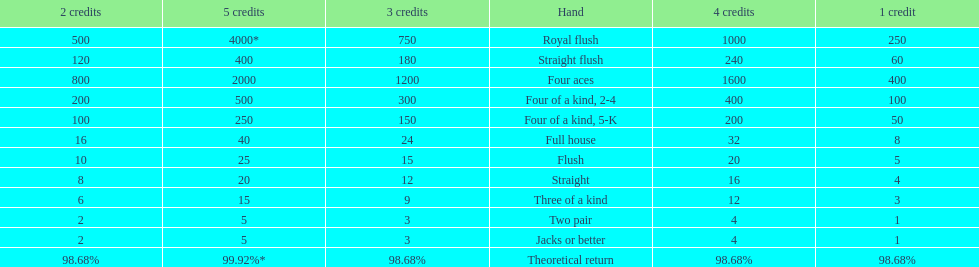What's the best type of four of a kind to win? Four of a kind, 2-4. Can you give me this table as a dict? {'header': ['2 credits', '5 credits', '3 credits', 'Hand', '4 credits', '1 credit'], 'rows': [['500', '4000*', '750', 'Royal flush', '1000', '250'], ['120', '400', '180', 'Straight flush', '240', '60'], ['800', '2000', '1200', 'Four aces', '1600', '400'], ['200', '500', '300', 'Four of a kind, 2-4', '400', '100'], ['100', '250', '150', 'Four of a kind, 5-K', '200', '50'], ['16', '40', '24', 'Full house', '32', '8'], ['10', '25', '15', 'Flush', '20', '5'], ['8', '20', '12', 'Straight', '16', '4'], ['6', '15', '9', 'Three of a kind', '12', '3'], ['2', '5', '3', 'Two pair', '4', '1'], ['2', '5', '3', 'Jacks or better', '4', '1'], ['98.68%', '99.92%*', '98.68%', 'Theoretical return', '98.68%', '98.68%']]} 